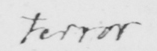Please provide the text content of this handwritten line. terror 